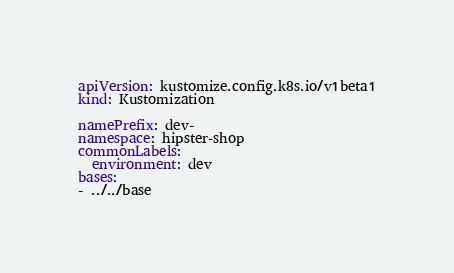Convert code to text. <code><loc_0><loc_0><loc_500><loc_500><_YAML_>apiVersion: kustomize.config.k8s.io/v1beta1
kind: Kustomization

namePrefix: dev-
namespace: hipster-shop
commonLabels:
  environment: dev
bases:
- ../../base
</code> 